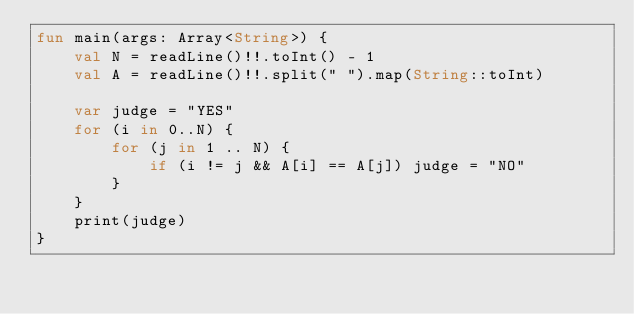Convert code to text. <code><loc_0><loc_0><loc_500><loc_500><_Kotlin_>fun main(args: Array<String>) {
    val N = readLine()!!.toInt() - 1
    val A = readLine()!!.split(" ").map(String::toInt)

    var judge = "YES"
    for (i in 0..N) {
        for (j in 1 .. N) {
            if (i != j && A[i] == A[j]) judge = "NO"
        }
    }
    print(judge)
}</code> 